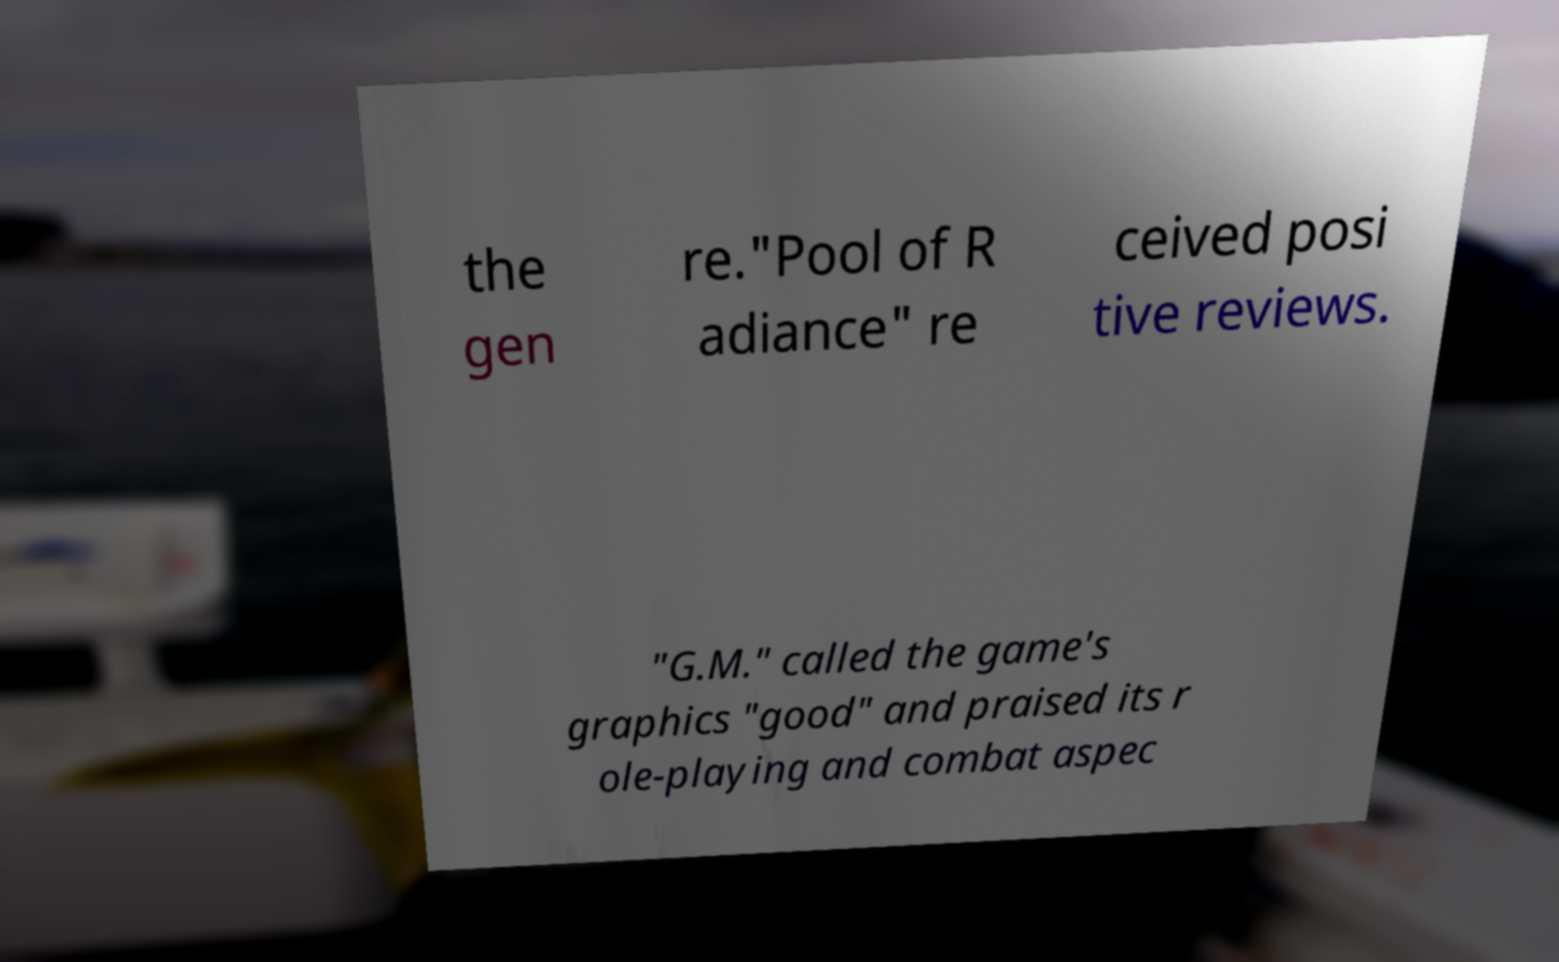Could you extract and type out the text from this image? the gen re."Pool of R adiance" re ceived posi tive reviews. "G.M." called the game's graphics "good" and praised its r ole-playing and combat aspec 